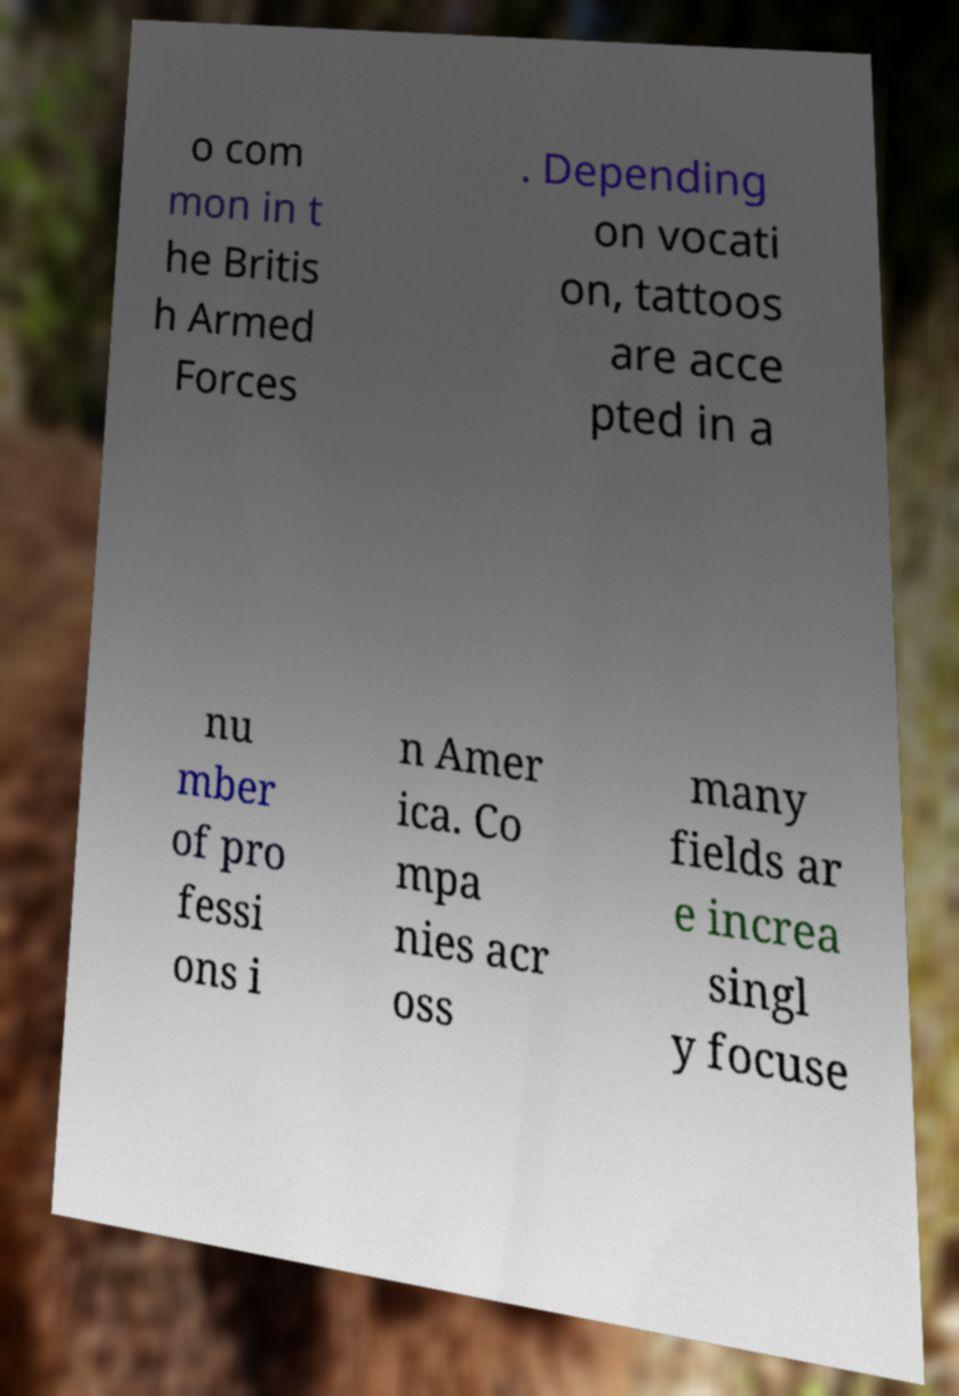For documentation purposes, I need the text within this image transcribed. Could you provide that? o com mon in t he Britis h Armed Forces . Depending on vocati on, tattoos are acce pted in a nu mber of pro fessi ons i n Amer ica. Co mpa nies acr oss many fields ar e increa singl y focuse 